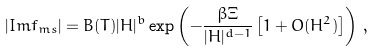Convert formula to latex. <formula><loc_0><loc_0><loc_500><loc_500>| I m f _ { m s } | = B ( T ) | H | ^ { b } \exp \left ( - \frac { \beta \Xi } { | H | ^ { d - 1 } } \left [ 1 + O ( H ^ { 2 } ) \right ] \right ) \, ,</formula> 